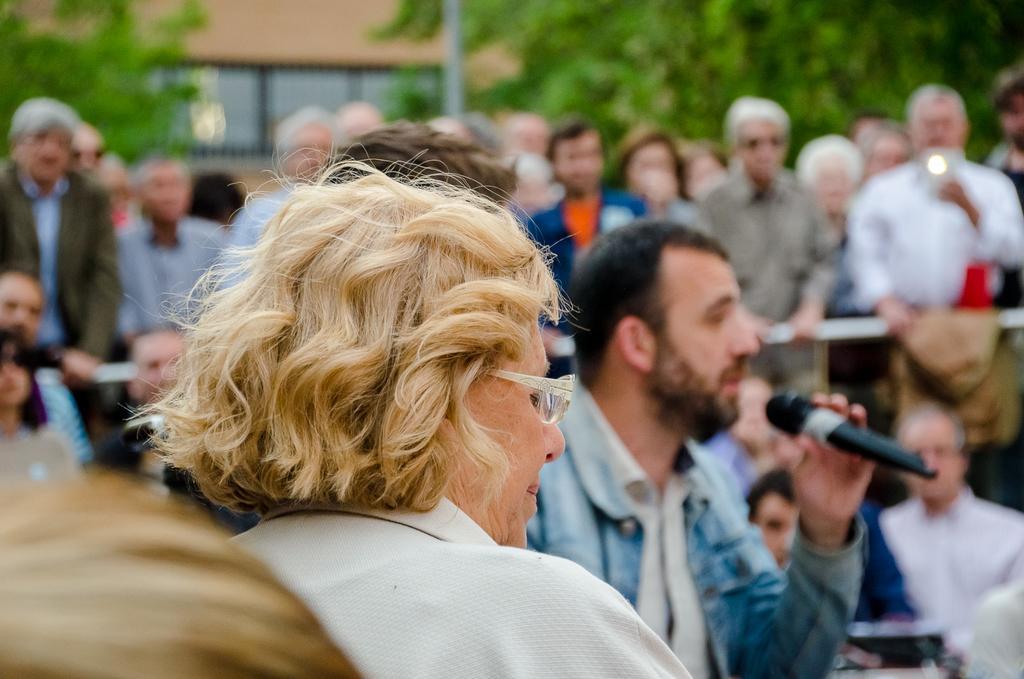How would you summarize this image in a sentence or two? in this image there is a person with white color spectacles, another man holding a mike and at the back ground there are group of people standing, building, pole, tree. 